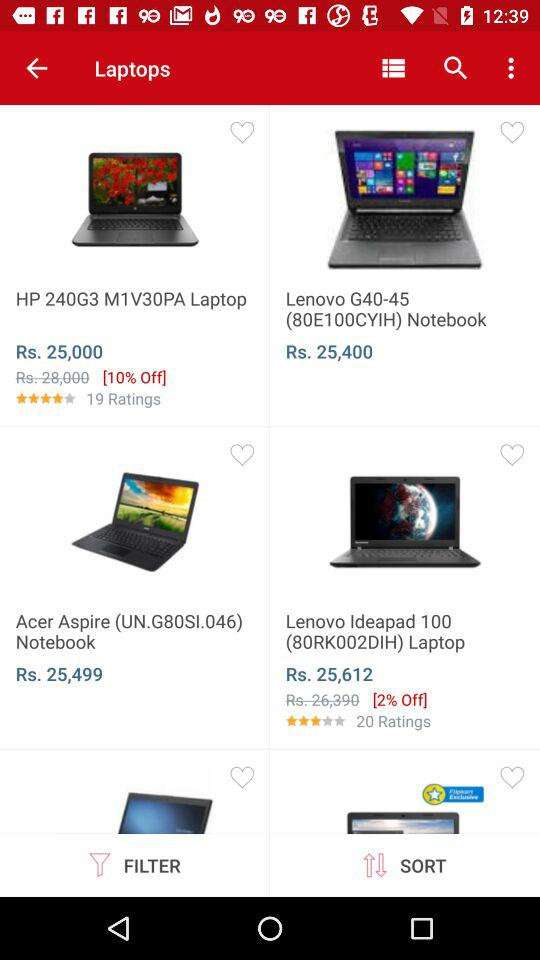What is the rating of "HP 240G3"? The rating of "HP 240G3" is 4 stars. 